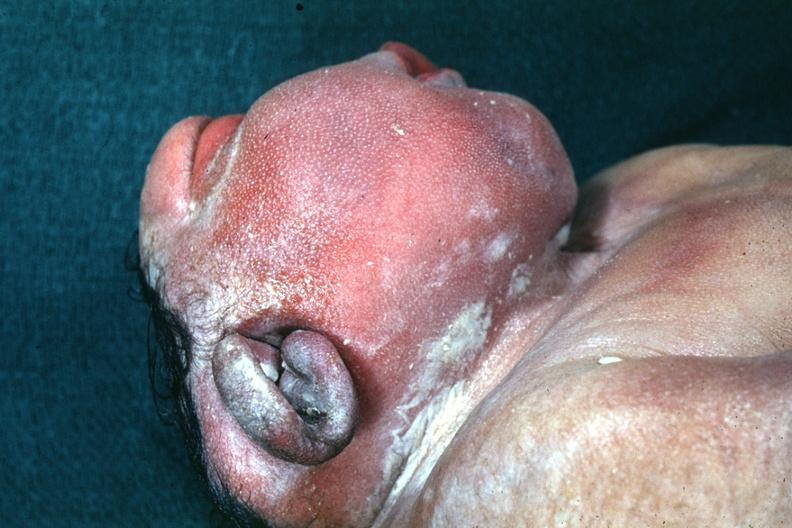does conjoined twins show lateral view of head typical example?
Answer the question using a single word or phrase. No 